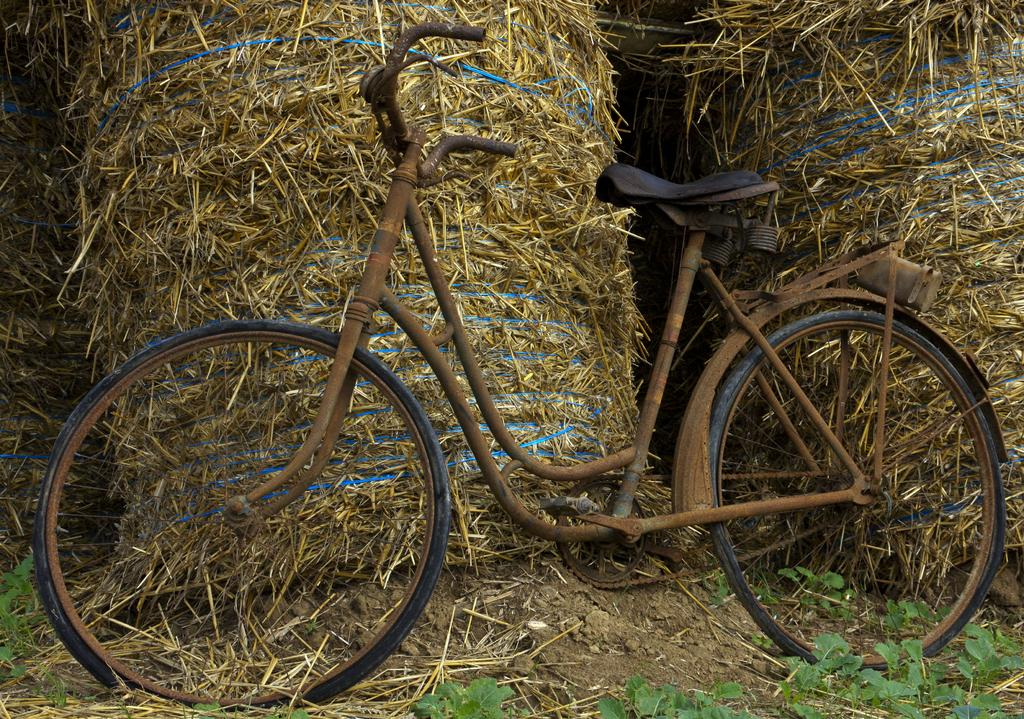What is the main subject in the foreground of the image? There is an old cycle in the foreground of the image. How is the cycle positioned in relation to other objects in the image? The cycle is leaning against hay bales. What type of vegetation can be seen in the image? There are small plants visible in the image. Can you tell me how many cups of coffee the men are holding in the image? There are no cups of coffee or men present in the image; it features an old cycle leaning against hay bales and small plants. 